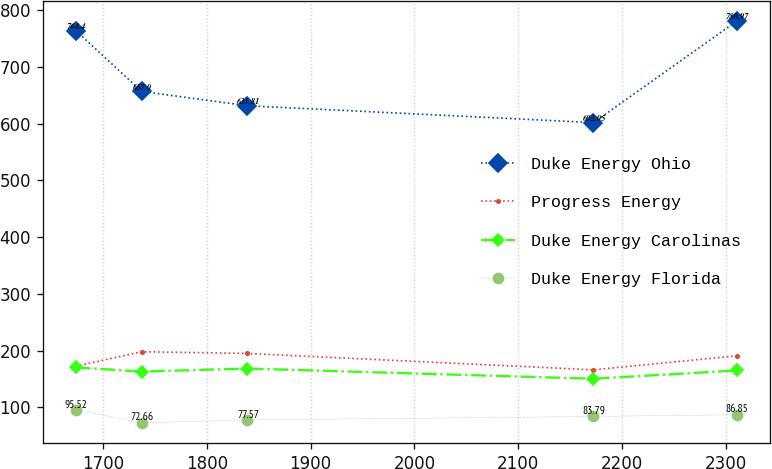Convert chart. <chart><loc_0><loc_0><loc_500><loc_500><line_chart><ecel><fcel>Duke Energy Ohio<fcel>Progress Energy<fcel>Duke Energy Carolinas<fcel>Duke Energy Florida<nl><fcel>1673.74<fcel>764.4<fcel>172.39<fcel>170.24<fcel>95.52<nl><fcel>1737.39<fcel>657<fcel>197.97<fcel>162.94<fcel>72.66<nl><fcel>1839.19<fcel>631.81<fcel>194.92<fcel>168.28<fcel>77.57<nl><fcel>2172.36<fcel>602.05<fcel>165.96<fcel>150.31<fcel>83.79<nl><fcel>2310.27<fcel>780.97<fcel>190.79<fcel>164.9<fcel>86.85<nl></chart> 